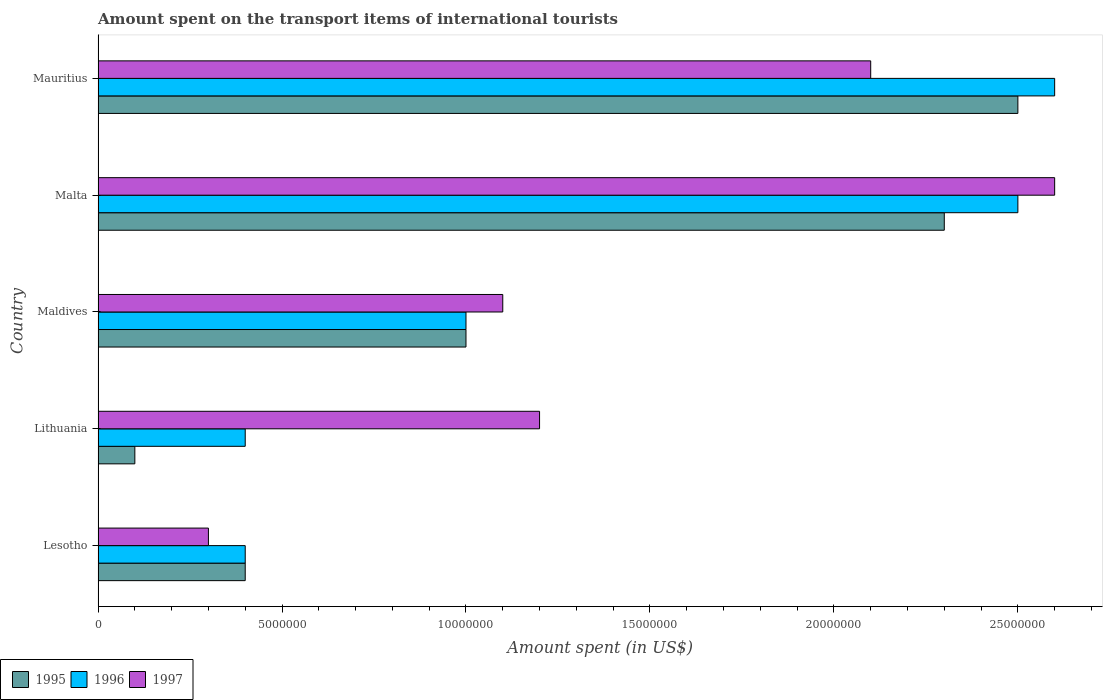How many groups of bars are there?
Offer a terse response. 5. How many bars are there on the 2nd tick from the bottom?
Keep it short and to the point. 3. What is the label of the 1st group of bars from the top?
Give a very brief answer. Mauritius. In how many cases, is the number of bars for a given country not equal to the number of legend labels?
Ensure brevity in your answer.  0. What is the amount spent on the transport items of international tourists in 1997 in Lesotho?
Your response must be concise. 3.00e+06. Across all countries, what is the maximum amount spent on the transport items of international tourists in 1995?
Provide a short and direct response. 2.50e+07. In which country was the amount spent on the transport items of international tourists in 1995 maximum?
Offer a terse response. Mauritius. In which country was the amount spent on the transport items of international tourists in 1997 minimum?
Your response must be concise. Lesotho. What is the total amount spent on the transport items of international tourists in 1996 in the graph?
Your answer should be very brief. 6.90e+07. What is the difference between the amount spent on the transport items of international tourists in 1995 in Maldives and that in Malta?
Your response must be concise. -1.30e+07. What is the difference between the amount spent on the transport items of international tourists in 1997 in Mauritius and the amount spent on the transport items of international tourists in 1996 in Lithuania?
Ensure brevity in your answer.  1.70e+07. What is the average amount spent on the transport items of international tourists in 1997 per country?
Your answer should be very brief. 1.46e+07. In how many countries, is the amount spent on the transport items of international tourists in 1995 greater than 24000000 US$?
Offer a very short reply. 1. What is the ratio of the amount spent on the transport items of international tourists in 1995 in Lithuania to that in Malta?
Provide a succinct answer. 0.04. Is the amount spent on the transport items of international tourists in 1996 in Lithuania less than that in Maldives?
Ensure brevity in your answer.  Yes. What is the difference between the highest and the second highest amount spent on the transport items of international tourists in 1996?
Ensure brevity in your answer.  1.00e+06. What is the difference between the highest and the lowest amount spent on the transport items of international tourists in 1996?
Offer a terse response. 2.20e+07. How many bars are there?
Provide a succinct answer. 15. Are all the bars in the graph horizontal?
Provide a short and direct response. Yes. Are the values on the major ticks of X-axis written in scientific E-notation?
Give a very brief answer. No. Where does the legend appear in the graph?
Your answer should be compact. Bottom left. What is the title of the graph?
Offer a very short reply. Amount spent on the transport items of international tourists. Does "2000" appear as one of the legend labels in the graph?
Your answer should be very brief. No. What is the label or title of the X-axis?
Provide a short and direct response. Amount spent (in US$). What is the Amount spent (in US$) in 1996 in Lithuania?
Offer a very short reply. 4.00e+06. What is the Amount spent (in US$) in 1995 in Maldives?
Your answer should be compact. 1.00e+07. What is the Amount spent (in US$) in 1996 in Maldives?
Keep it short and to the point. 1.00e+07. What is the Amount spent (in US$) of 1997 in Maldives?
Provide a short and direct response. 1.10e+07. What is the Amount spent (in US$) in 1995 in Malta?
Make the answer very short. 2.30e+07. What is the Amount spent (in US$) of 1996 in Malta?
Keep it short and to the point. 2.50e+07. What is the Amount spent (in US$) in 1997 in Malta?
Your response must be concise. 2.60e+07. What is the Amount spent (in US$) of 1995 in Mauritius?
Provide a short and direct response. 2.50e+07. What is the Amount spent (in US$) of 1996 in Mauritius?
Offer a very short reply. 2.60e+07. What is the Amount spent (in US$) of 1997 in Mauritius?
Your response must be concise. 2.10e+07. Across all countries, what is the maximum Amount spent (in US$) in 1995?
Provide a succinct answer. 2.50e+07. Across all countries, what is the maximum Amount spent (in US$) of 1996?
Your answer should be compact. 2.60e+07. Across all countries, what is the maximum Amount spent (in US$) of 1997?
Provide a succinct answer. 2.60e+07. Across all countries, what is the minimum Amount spent (in US$) of 1995?
Give a very brief answer. 1.00e+06. What is the total Amount spent (in US$) in 1995 in the graph?
Make the answer very short. 6.30e+07. What is the total Amount spent (in US$) of 1996 in the graph?
Make the answer very short. 6.90e+07. What is the total Amount spent (in US$) of 1997 in the graph?
Offer a terse response. 7.30e+07. What is the difference between the Amount spent (in US$) in 1995 in Lesotho and that in Lithuania?
Ensure brevity in your answer.  3.00e+06. What is the difference between the Amount spent (in US$) of 1997 in Lesotho and that in Lithuania?
Your response must be concise. -9.00e+06. What is the difference between the Amount spent (in US$) of 1995 in Lesotho and that in Maldives?
Provide a succinct answer. -6.00e+06. What is the difference between the Amount spent (in US$) in 1996 in Lesotho and that in Maldives?
Keep it short and to the point. -6.00e+06. What is the difference between the Amount spent (in US$) of 1997 in Lesotho and that in Maldives?
Ensure brevity in your answer.  -8.00e+06. What is the difference between the Amount spent (in US$) in 1995 in Lesotho and that in Malta?
Your response must be concise. -1.90e+07. What is the difference between the Amount spent (in US$) of 1996 in Lesotho and that in Malta?
Provide a short and direct response. -2.10e+07. What is the difference between the Amount spent (in US$) in 1997 in Lesotho and that in Malta?
Offer a very short reply. -2.30e+07. What is the difference between the Amount spent (in US$) in 1995 in Lesotho and that in Mauritius?
Your response must be concise. -2.10e+07. What is the difference between the Amount spent (in US$) of 1996 in Lesotho and that in Mauritius?
Provide a succinct answer. -2.20e+07. What is the difference between the Amount spent (in US$) in 1997 in Lesotho and that in Mauritius?
Your answer should be very brief. -1.80e+07. What is the difference between the Amount spent (in US$) of 1995 in Lithuania and that in Maldives?
Give a very brief answer. -9.00e+06. What is the difference between the Amount spent (in US$) of 1996 in Lithuania and that in Maldives?
Keep it short and to the point. -6.00e+06. What is the difference between the Amount spent (in US$) in 1995 in Lithuania and that in Malta?
Ensure brevity in your answer.  -2.20e+07. What is the difference between the Amount spent (in US$) of 1996 in Lithuania and that in Malta?
Offer a terse response. -2.10e+07. What is the difference between the Amount spent (in US$) of 1997 in Lithuania and that in Malta?
Your answer should be compact. -1.40e+07. What is the difference between the Amount spent (in US$) of 1995 in Lithuania and that in Mauritius?
Offer a terse response. -2.40e+07. What is the difference between the Amount spent (in US$) of 1996 in Lithuania and that in Mauritius?
Offer a very short reply. -2.20e+07. What is the difference between the Amount spent (in US$) in 1997 in Lithuania and that in Mauritius?
Your answer should be very brief. -9.00e+06. What is the difference between the Amount spent (in US$) in 1995 in Maldives and that in Malta?
Provide a succinct answer. -1.30e+07. What is the difference between the Amount spent (in US$) of 1996 in Maldives and that in Malta?
Keep it short and to the point. -1.50e+07. What is the difference between the Amount spent (in US$) of 1997 in Maldives and that in Malta?
Provide a succinct answer. -1.50e+07. What is the difference between the Amount spent (in US$) of 1995 in Maldives and that in Mauritius?
Provide a short and direct response. -1.50e+07. What is the difference between the Amount spent (in US$) of 1996 in Maldives and that in Mauritius?
Offer a terse response. -1.60e+07. What is the difference between the Amount spent (in US$) of 1997 in Maldives and that in Mauritius?
Offer a terse response. -1.00e+07. What is the difference between the Amount spent (in US$) of 1995 in Lesotho and the Amount spent (in US$) of 1996 in Lithuania?
Offer a terse response. 0. What is the difference between the Amount spent (in US$) in 1995 in Lesotho and the Amount spent (in US$) in 1997 in Lithuania?
Ensure brevity in your answer.  -8.00e+06. What is the difference between the Amount spent (in US$) in 1996 in Lesotho and the Amount spent (in US$) in 1997 in Lithuania?
Keep it short and to the point. -8.00e+06. What is the difference between the Amount spent (in US$) in 1995 in Lesotho and the Amount spent (in US$) in 1996 in Maldives?
Offer a terse response. -6.00e+06. What is the difference between the Amount spent (in US$) of 1995 in Lesotho and the Amount spent (in US$) of 1997 in Maldives?
Your answer should be very brief. -7.00e+06. What is the difference between the Amount spent (in US$) in 1996 in Lesotho and the Amount spent (in US$) in 1997 in Maldives?
Keep it short and to the point. -7.00e+06. What is the difference between the Amount spent (in US$) of 1995 in Lesotho and the Amount spent (in US$) of 1996 in Malta?
Your answer should be compact. -2.10e+07. What is the difference between the Amount spent (in US$) in 1995 in Lesotho and the Amount spent (in US$) in 1997 in Malta?
Offer a terse response. -2.20e+07. What is the difference between the Amount spent (in US$) in 1996 in Lesotho and the Amount spent (in US$) in 1997 in Malta?
Provide a short and direct response. -2.20e+07. What is the difference between the Amount spent (in US$) in 1995 in Lesotho and the Amount spent (in US$) in 1996 in Mauritius?
Your answer should be very brief. -2.20e+07. What is the difference between the Amount spent (in US$) in 1995 in Lesotho and the Amount spent (in US$) in 1997 in Mauritius?
Offer a very short reply. -1.70e+07. What is the difference between the Amount spent (in US$) in 1996 in Lesotho and the Amount spent (in US$) in 1997 in Mauritius?
Make the answer very short. -1.70e+07. What is the difference between the Amount spent (in US$) in 1995 in Lithuania and the Amount spent (in US$) in 1996 in Maldives?
Make the answer very short. -9.00e+06. What is the difference between the Amount spent (in US$) in 1995 in Lithuania and the Amount spent (in US$) in 1997 in Maldives?
Provide a succinct answer. -1.00e+07. What is the difference between the Amount spent (in US$) in 1996 in Lithuania and the Amount spent (in US$) in 1997 in Maldives?
Make the answer very short. -7.00e+06. What is the difference between the Amount spent (in US$) of 1995 in Lithuania and the Amount spent (in US$) of 1996 in Malta?
Your answer should be compact. -2.40e+07. What is the difference between the Amount spent (in US$) in 1995 in Lithuania and the Amount spent (in US$) in 1997 in Malta?
Provide a succinct answer. -2.50e+07. What is the difference between the Amount spent (in US$) of 1996 in Lithuania and the Amount spent (in US$) of 1997 in Malta?
Give a very brief answer. -2.20e+07. What is the difference between the Amount spent (in US$) in 1995 in Lithuania and the Amount spent (in US$) in 1996 in Mauritius?
Your answer should be compact. -2.50e+07. What is the difference between the Amount spent (in US$) in 1995 in Lithuania and the Amount spent (in US$) in 1997 in Mauritius?
Make the answer very short. -2.00e+07. What is the difference between the Amount spent (in US$) of 1996 in Lithuania and the Amount spent (in US$) of 1997 in Mauritius?
Offer a terse response. -1.70e+07. What is the difference between the Amount spent (in US$) of 1995 in Maldives and the Amount spent (in US$) of 1996 in Malta?
Ensure brevity in your answer.  -1.50e+07. What is the difference between the Amount spent (in US$) of 1995 in Maldives and the Amount spent (in US$) of 1997 in Malta?
Make the answer very short. -1.60e+07. What is the difference between the Amount spent (in US$) in 1996 in Maldives and the Amount spent (in US$) in 1997 in Malta?
Your answer should be very brief. -1.60e+07. What is the difference between the Amount spent (in US$) in 1995 in Maldives and the Amount spent (in US$) in 1996 in Mauritius?
Your answer should be compact. -1.60e+07. What is the difference between the Amount spent (in US$) of 1995 in Maldives and the Amount spent (in US$) of 1997 in Mauritius?
Give a very brief answer. -1.10e+07. What is the difference between the Amount spent (in US$) of 1996 in Maldives and the Amount spent (in US$) of 1997 in Mauritius?
Provide a short and direct response. -1.10e+07. What is the difference between the Amount spent (in US$) of 1995 in Malta and the Amount spent (in US$) of 1996 in Mauritius?
Give a very brief answer. -3.00e+06. What is the difference between the Amount spent (in US$) of 1996 in Malta and the Amount spent (in US$) of 1997 in Mauritius?
Your answer should be compact. 4.00e+06. What is the average Amount spent (in US$) of 1995 per country?
Give a very brief answer. 1.26e+07. What is the average Amount spent (in US$) in 1996 per country?
Ensure brevity in your answer.  1.38e+07. What is the average Amount spent (in US$) in 1997 per country?
Provide a succinct answer. 1.46e+07. What is the difference between the Amount spent (in US$) of 1995 and Amount spent (in US$) of 1997 in Lesotho?
Provide a succinct answer. 1.00e+06. What is the difference between the Amount spent (in US$) in 1996 and Amount spent (in US$) in 1997 in Lesotho?
Make the answer very short. 1.00e+06. What is the difference between the Amount spent (in US$) in 1995 and Amount spent (in US$) in 1997 in Lithuania?
Provide a succinct answer. -1.10e+07. What is the difference between the Amount spent (in US$) in 1996 and Amount spent (in US$) in 1997 in Lithuania?
Your response must be concise. -8.00e+06. What is the difference between the Amount spent (in US$) in 1996 and Amount spent (in US$) in 1997 in Maldives?
Provide a short and direct response. -1.00e+06. What is the difference between the Amount spent (in US$) in 1995 and Amount spent (in US$) in 1996 in Malta?
Make the answer very short. -2.00e+06. What is the difference between the Amount spent (in US$) of 1996 and Amount spent (in US$) of 1997 in Malta?
Provide a short and direct response. -1.00e+06. What is the difference between the Amount spent (in US$) of 1995 and Amount spent (in US$) of 1996 in Mauritius?
Make the answer very short. -1.00e+06. What is the ratio of the Amount spent (in US$) in 1995 in Lesotho to that in Lithuania?
Provide a short and direct response. 4. What is the ratio of the Amount spent (in US$) of 1996 in Lesotho to that in Lithuania?
Give a very brief answer. 1. What is the ratio of the Amount spent (in US$) of 1997 in Lesotho to that in Lithuania?
Make the answer very short. 0.25. What is the ratio of the Amount spent (in US$) in 1996 in Lesotho to that in Maldives?
Your response must be concise. 0.4. What is the ratio of the Amount spent (in US$) in 1997 in Lesotho to that in Maldives?
Your response must be concise. 0.27. What is the ratio of the Amount spent (in US$) of 1995 in Lesotho to that in Malta?
Keep it short and to the point. 0.17. What is the ratio of the Amount spent (in US$) of 1996 in Lesotho to that in Malta?
Your answer should be very brief. 0.16. What is the ratio of the Amount spent (in US$) of 1997 in Lesotho to that in Malta?
Give a very brief answer. 0.12. What is the ratio of the Amount spent (in US$) in 1995 in Lesotho to that in Mauritius?
Keep it short and to the point. 0.16. What is the ratio of the Amount spent (in US$) in 1996 in Lesotho to that in Mauritius?
Keep it short and to the point. 0.15. What is the ratio of the Amount spent (in US$) in 1997 in Lesotho to that in Mauritius?
Provide a succinct answer. 0.14. What is the ratio of the Amount spent (in US$) in 1996 in Lithuania to that in Maldives?
Your response must be concise. 0.4. What is the ratio of the Amount spent (in US$) of 1995 in Lithuania to that in Malta?
Provide a short and direct response. 0.04. What is the ratio of the Amount spent (in US$) of 1996 in Lithuania to that in Malta?
Offer a very short reply. 0.16. What is the ratio of the Amount spent (in US$) in 1997 in Lithuania to that in Malta?
Provide a succinct answer. 0.46. What is the ratio of the Amount spent (in US$) of 1995 in Lithuania to that in Mauritius?
Offer a terse response. 0.04. What is the ratio of the Amount spent (in US$) in 1996 in Lithuania to that in Mauritius?
Offer a terse response. 0.15. What is the ratio of the Amount spent (in US$) of 1995 in Maldives to that in Malta?
Your answer should be compact. 0.43. What is the ratio of the Amount spent (in US$) in 1997 in Maldives to that in Malta?
Ensure brevity in your answer.  0.42. What is the ratio of the Amount spent (in US$) in 1995 in Maldives to that in Mauritius?
Keep it short and to the point. 0.4. What is the ratio of the Amount spent (in US$) of 1996 in Maldives to that in Mauritius?
Provide a succinct answer. 0.38. What is the ratio of the Amount spent (in US$) in 1997 in Maldives to that in Mauritius?
Keep it short and to the point. 0.52. What is the ratio of the Amount spent (in US$) in 1995 in Malta to that in Mauritius?
Give a very brief answer. 0.92. What is the ratio of the Amount spent (in US$) in 1996 in Malta to that in Mauritius?
Your answer should be very brief. 0.96. What is the ratio of the Amount spent (in US$) of 1997 in Malta to that in Mauritius?
Keep it short and to the point. 1.24. What is the difference between the highest and the second highest Amount spent (in US$) of 1995?
Make the answer very short. 2.00e+06. What is the difference between the highest and the second highest Amount spent (in US$) in 1996?
Offer a terse response. 1.00e+06. What is the difference between the highest and the second highest Amount spent (in US$) in 1997?
Offer a very short reply. 5.00e+06. What is the difference between the highest and the lowest Amount spent (in US$) of 1995?
Provide a succinct answer. 2.40e+07. What is the difference between the highest and the lowest Amount spent (in US$) in 1996?
Keep it short and to the point. 2.20e+07. What is the difference between the highest and the lowest Amount spent (in US$) in 1997?
Provide a succinct answer. 2.30e+07. 